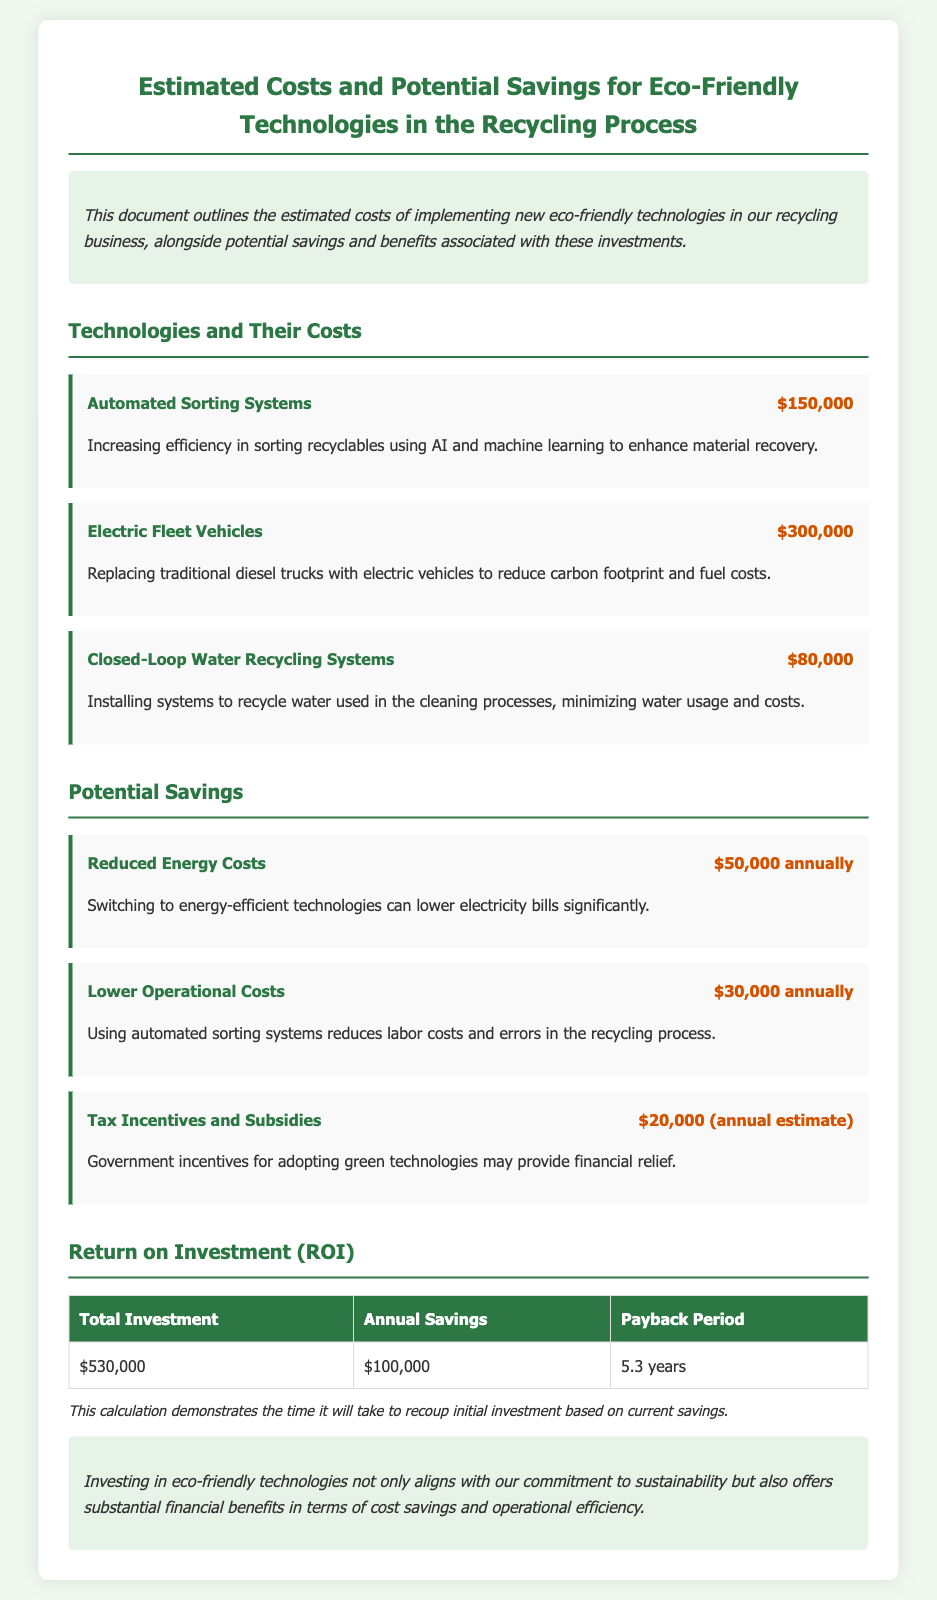What is the total investment? The total investment is provided in the ROI section of the document, which is $530,000.
Answer: $530,000 How much can be saved annually from reduced energy costs? The document states that switching to energy-efficient technologies can lower electricity bills by $50,000 annually.
Answer: $50,000 annually What is the cost of the Electric Fleet Vehicles? The cost for Electric Fleet Vehicles is listed under Technologies and Their Costs as $300,000.
Answer: $300,000 What is the estimated payback period? The payback period information can be found in the ROI table, which states it is 5.3 years.
Answer: 5.3 years What are the tax incentives and subsidies estimated at? The document mentions tax incentives and subsidies providing an annual estimate of $20,000.
Answer: $20,000 (annual estimate) How much can be saved annually from lower operational costs? The savings amount from lower operational costs is indicated as $30,000 annually.
Answer: $30,000 annually Which eco-friendly technology has the lowest cost? According to the document, the Closed-Loop Water Recycling Systems have the lowest cost at $80,000.
Answer: $80,000 What are the total annual savings from all sources listed? The total annual savings can be calculated by adding all annual savings amounts in the document: $50,000 + $30,000 + $20,000 = $100,000.
Answer: $100,000 annually 